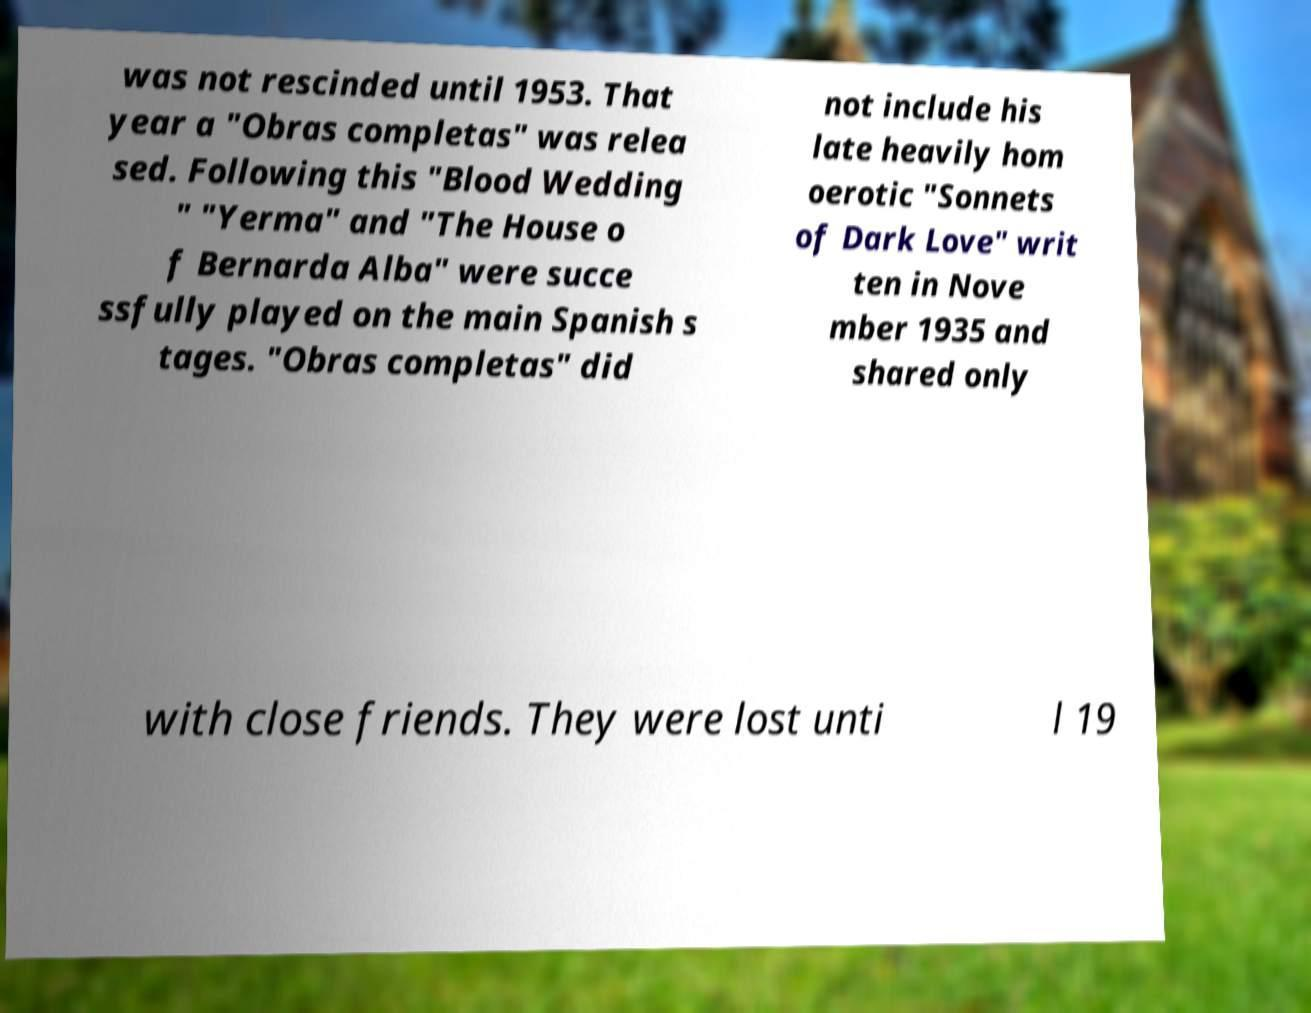Could you assist in decoding the text presented in this image and type it out clearly? was not rescinded until 1953. That year a "Obras completas" was relea sed. Following this "Blood Wedding " "Yerma" and "The House o f Bernarda Alba" were succe ssfully played on the main Spanish s tages. "Obras completas" did not include his late heavily hom oerotic "Sonnets of Dark Love" writ ten in Nove mber 1935 and shared only with close friends. They were lost unti l 19 